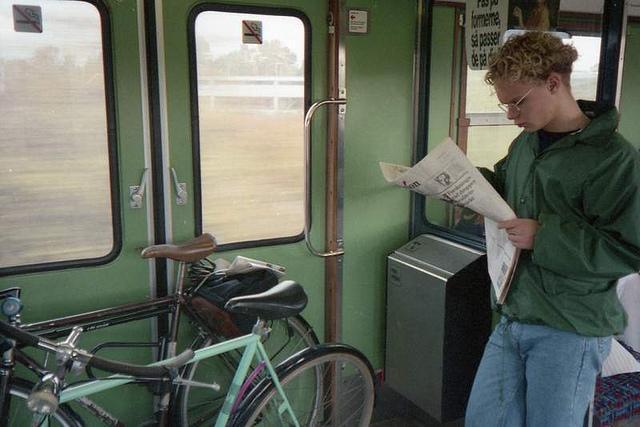How many bicycles can you see?
Give a very brief answer. 2. 